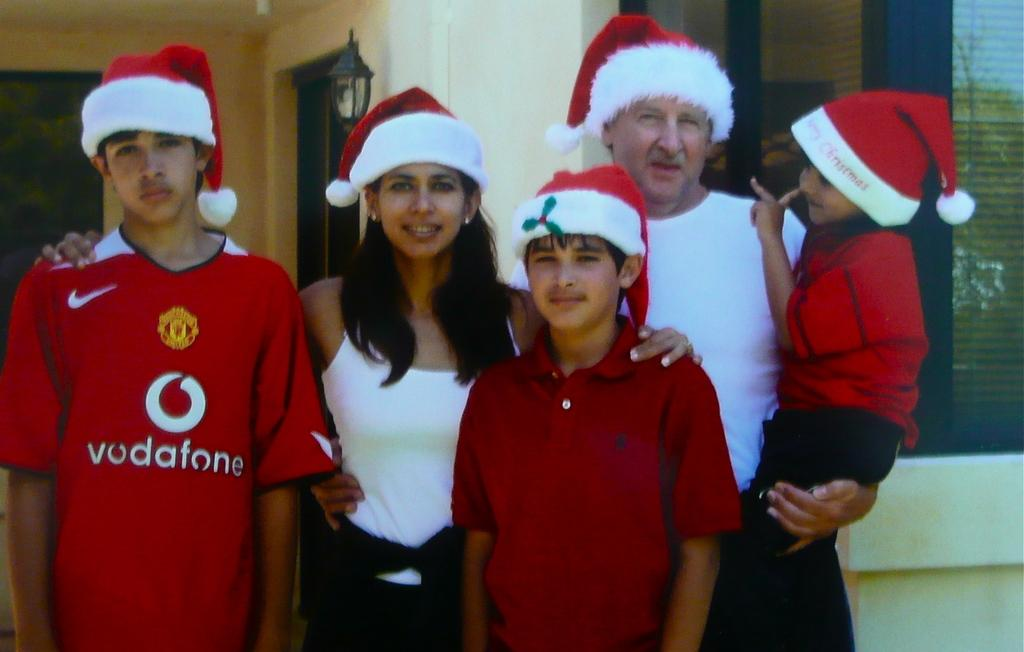<image>
Create a compact narrative representing the image presented. A stone faced teenager wears a shirt with the Vodafone name on it. 